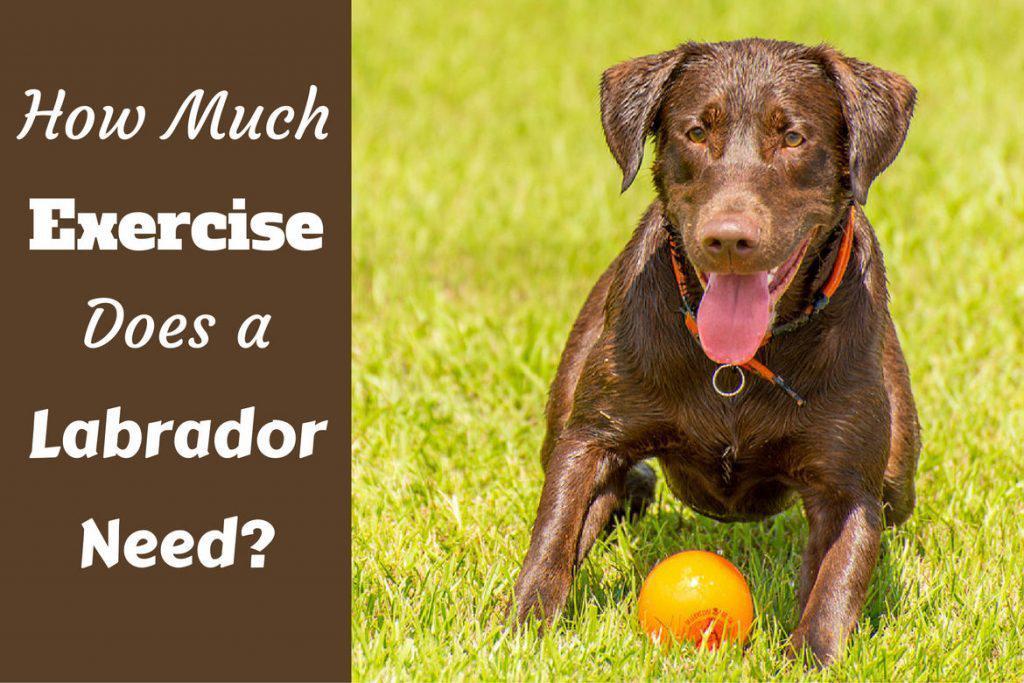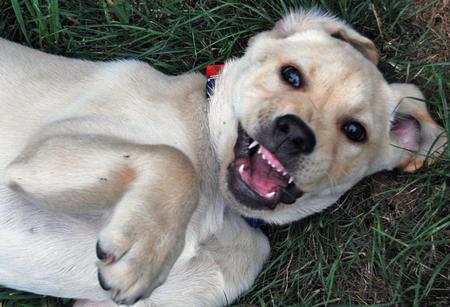The first image is the image on the left, the second image is the image on the right. Analyze the images presented: Is the assertion "An image shows an upright yellow lab baring its fangs, but not wearing any collar or muzzle." valid? Answer yes or no. No. The first image is the image on the left, the second image is the image on the right. Examine the images to the left and right. Is the description "One of the images contains a puppy." accurate? Answer yes or no. No. 